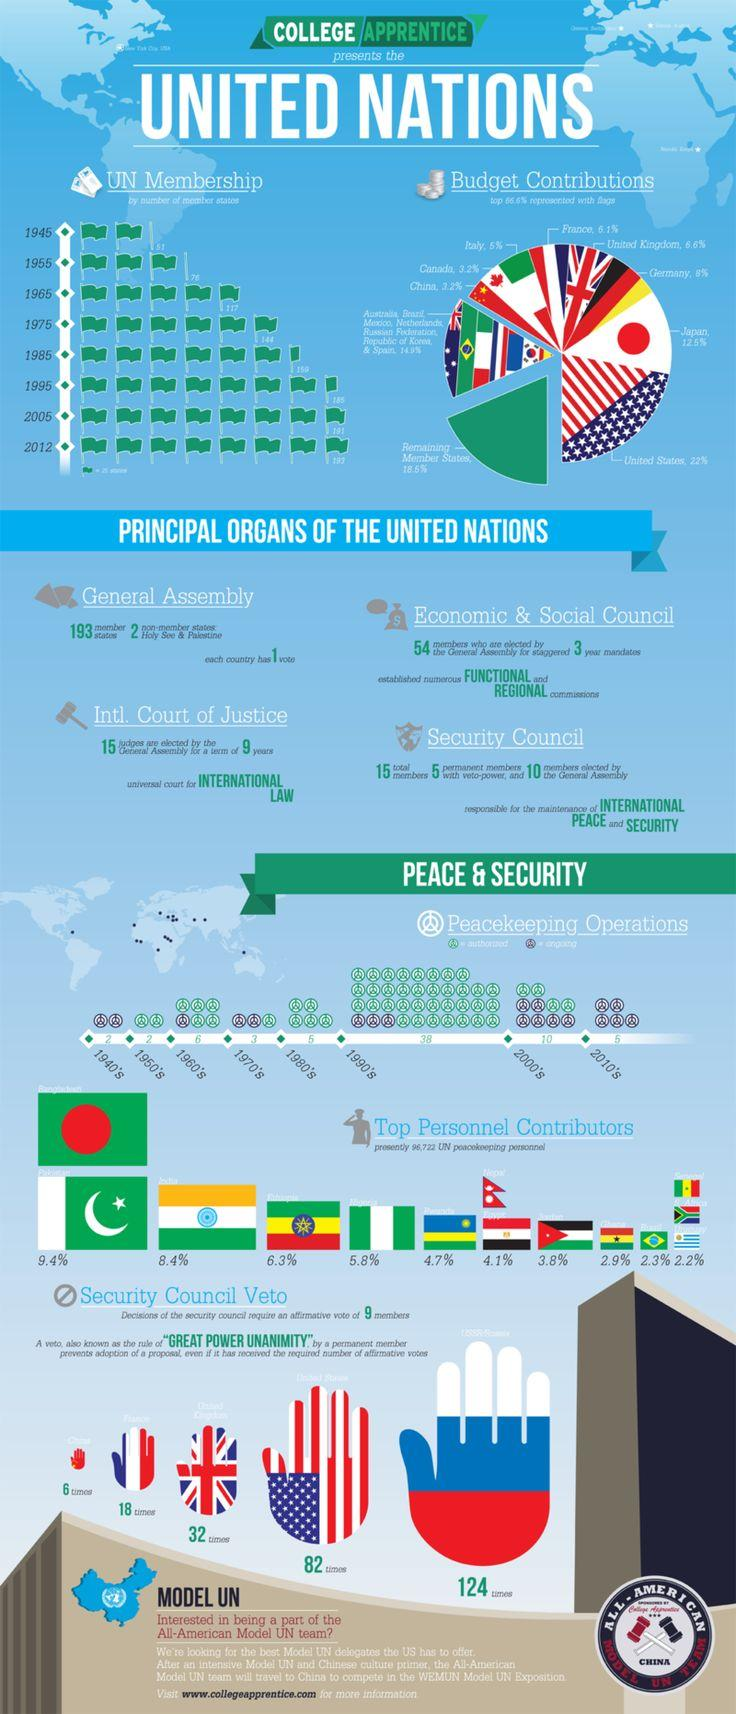Identify some key points in this picture. In 1945, there were 51 countries that were part of the United Nations. The budget for UN peacekeeping operations is contributed by various countries, including Italy, which contributes 5%. Canada's contribution to the UN peacekeeping operations budget is 3.2%. According to the UN, 6.3% of the peacekeeping personnel were contributed by Ethiopia. A significant percentage, 9.4%, of the UN peacekeeping personnel were contributed by Pakistan. 